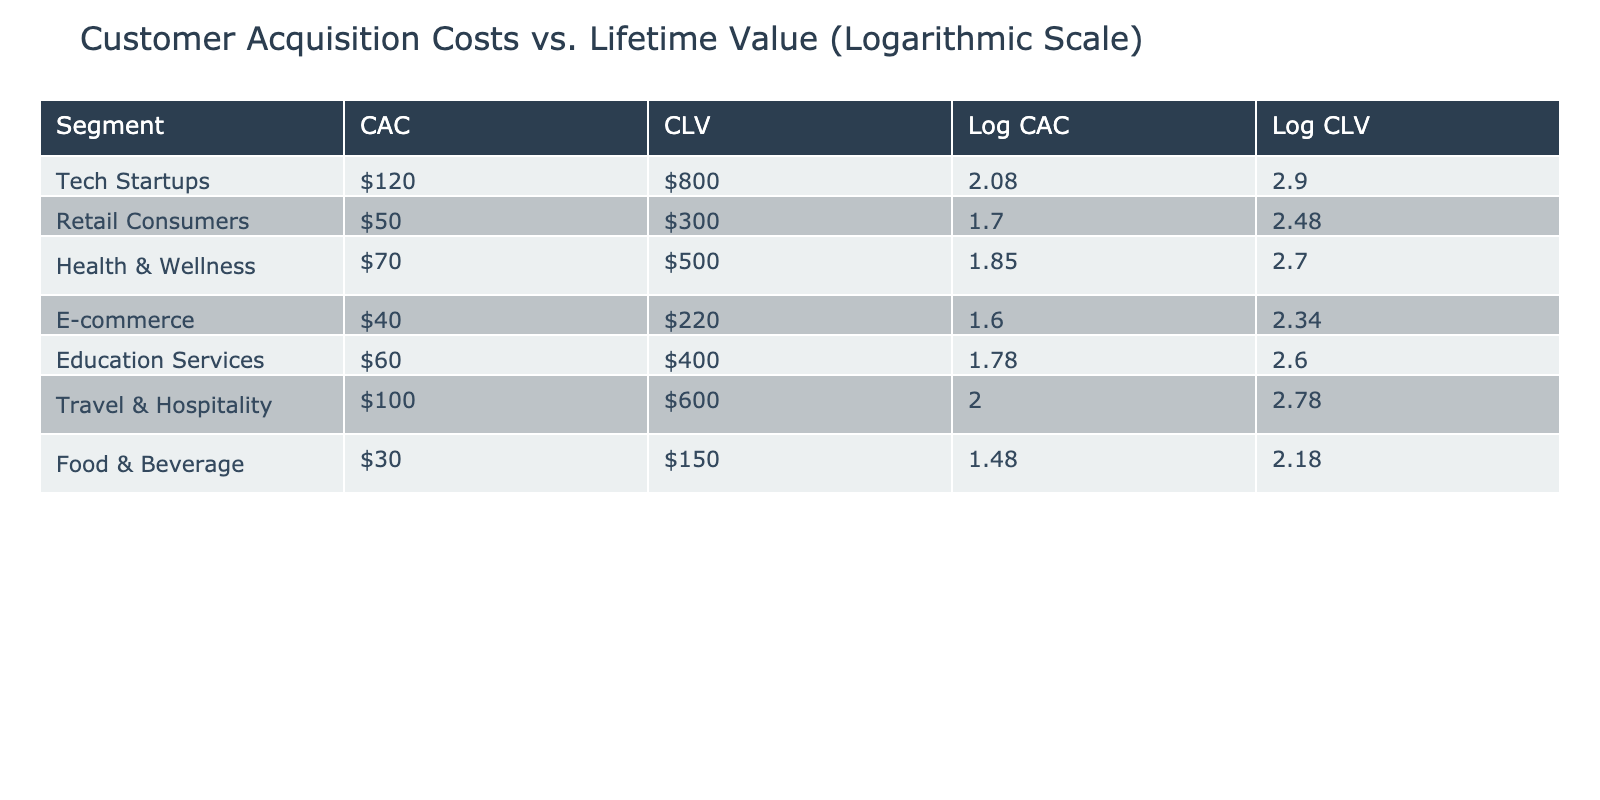What is the Customer Acquisition Cost for E-commerce? The table shows the Customer Acquisition Cost for E-commerce listed in the second column. It states that the cost is $40.
Answer: $40 Which segment has the highest Customer Lifetime Value? By looking at the third column, the Health & Wellness segment has the highest Customer Lifetime Value of $500, compared to the other segments.
Answer: Health & Wellness What is the difference between the average Customer Acquisition Cost and average Customer Lifetime Value? First, calculate the average for both. The total CAC is $120 + $50 + $70 + $40 + $60 + $100 + $30 = $470, and there are 7 segments, so average CAC is $470 / 7 ≈ $67.14. The total CLV is $800 + $300 + $500 + $220 + $400 + $600 + $150 = $2970, and so the average CLV is $2970 / 7 ≈ $423.86. The difference is $423.86 - $67.14 ≈ $356.72.
Answer: $356.72 Is it true that the Customer Acquisition Cost for Tech Startups is higher than for Food & Beverage? The table indicates that the Customer Acquisition Cost for Tech Startups is $120, while for Food & Beverage, it is $30. Therefore, $120 is greater than $30, confirming the statement is true.
Answer: True What is the logarithmic value of the Customer Lifetime Value for the Retail Consumers segment? The Customer Lifetime Value for Retail Consumers is $300. To find the logarithmic value, we apply log base 10: log10(300) approximately equals 2.48. Thus, the logarithmic value is 2.48.
Answer: 2.48 Which segment has the lowest ratio of Customer Acquisition Cost to Customer Lifetime Value, and what is that ratio? To find the ratio, we divide CAC by CLV for each segment. For Food & Beverage, CAC is $30 and CLV is $150, giving a ratio of 0.2. Other segments have higher ratios. Therefore, Food & Beverage has the lowest ratio of 0.2.
Answer: Food & Beverage, 0.2 Which segment has the highest Customer Acquisition Cost to Customer Lifetime Value ratio? Calculating each ratio, Tech Startups has a ratio of $120/$800 = 0.15, Retail Consumers $50/$300 = 0.166, Health & Wellness $70/$500 = 0.14, E-commerce $40/$220 = 0.181, Education Services $60/$400 = 0.15, Travel & Hospitality $100/$600 = 0.167, and Food & Beverage $30/$150 = 0.2. By comparison, Food & Beverage has the highest ratio.
Answer: Food & Beverage What is the logarithmic value of Customer Acquisition Cost for the Travel & Hospitality segment? The Customer Acquisition Cost for Travel & Hospitality is $100. The logarithmic value can be calculated as log10(100) which equals 2.00.
Answer: 2.00 